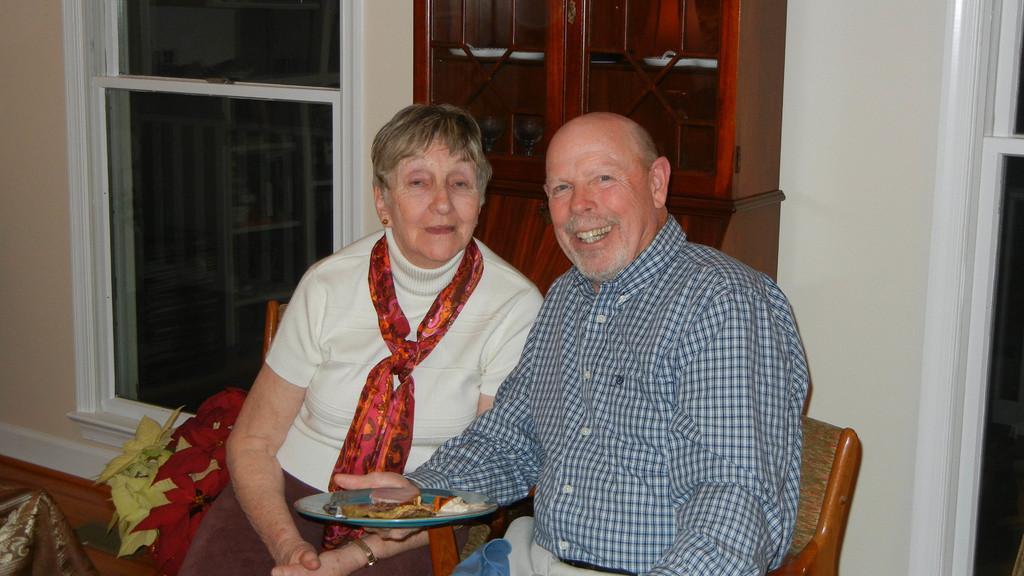Could you give a brief overview of what you see in this image? In this image we can see two persons sitting on the wooden chairs. Here we can see a man on the right side and there is a smile on his face. He is wearing a shirt and he is holding the plate in his hand. Here we can see a woman and there is a scarf on her neck. In the background, we can see the glass window. 